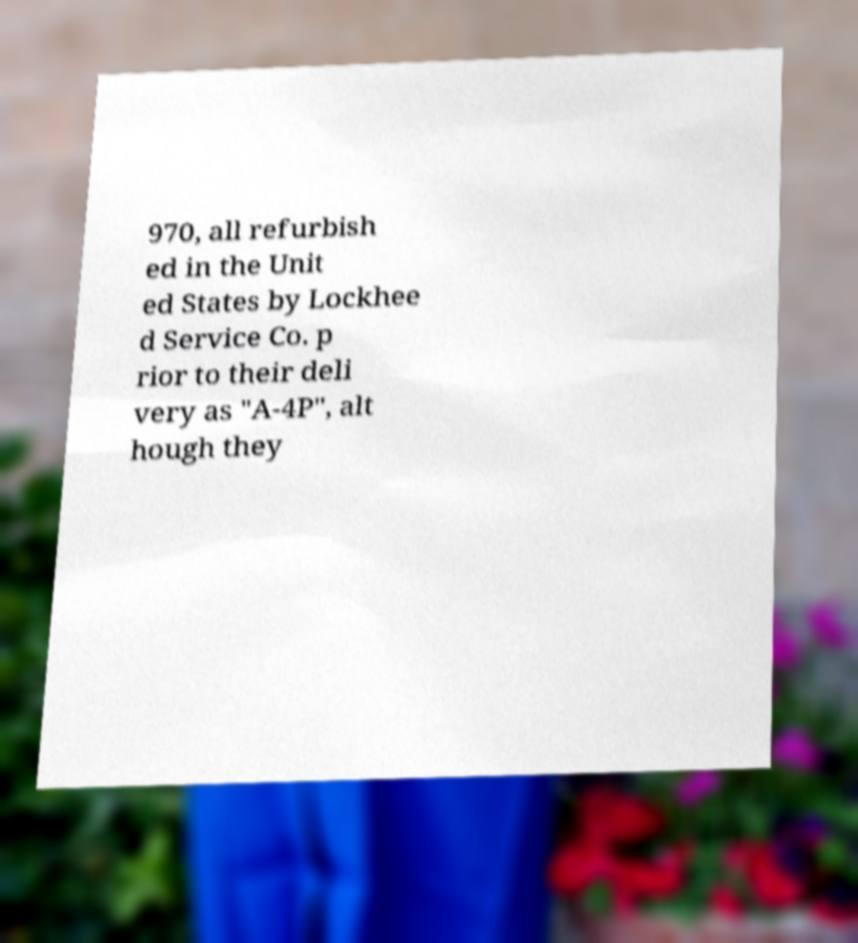Can you read and provide the text displayed in the image?This photo seems to have some interesting text. Can you extract and type it out for me? 970, all refurbish ed in the Unit ed States by Lockhee d Service Co. p rior to their deli very as "A-4P", alt hough they 